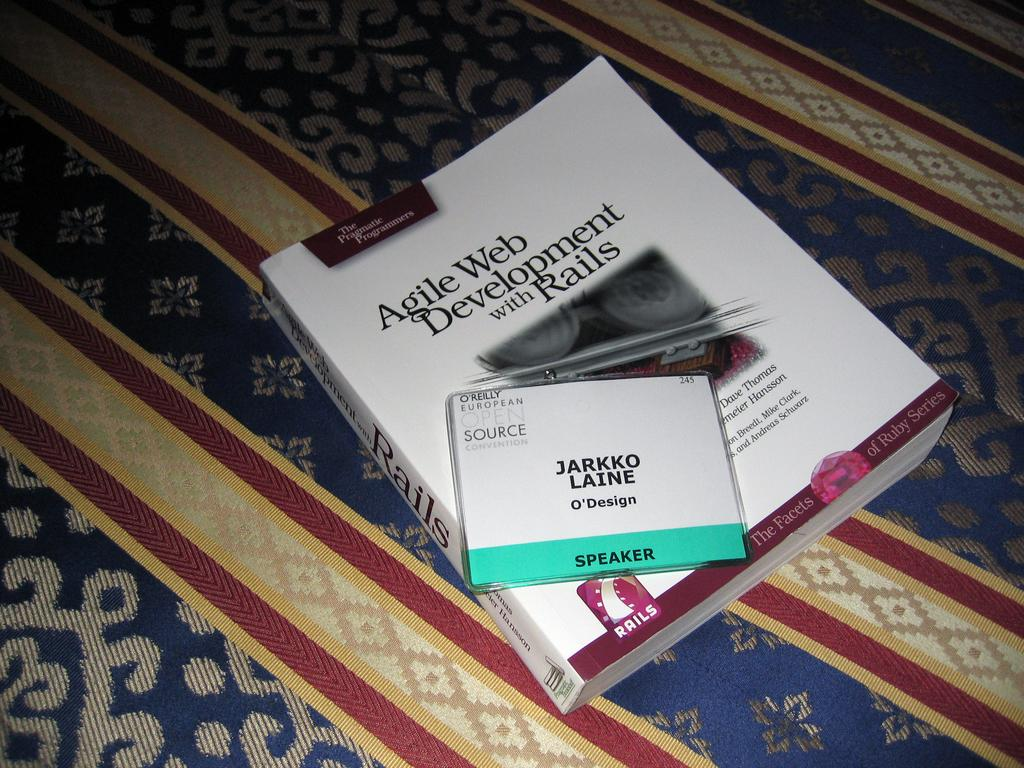<image>
Create a compact narrative representing the image presented. A book titled Agile Web Development with Rails is laying on a patterned surface. 